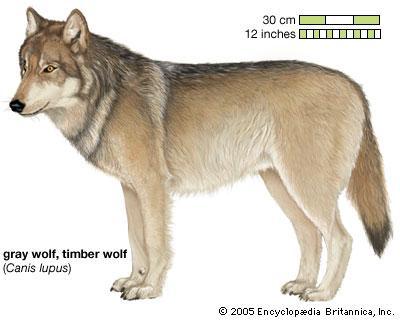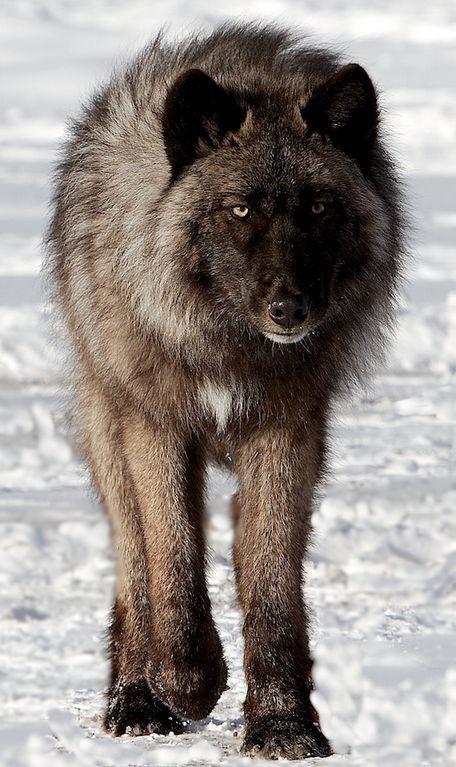The first image is the image on the left, the second image is the image on the right. Considering the images on both sides, is "A non-canine mammal can be seen in one or more of the images." valid? Answer yes or no. No. The first image is the image on the left, the second image is the image on the right. Considering the images on both sides, is "There are no more than two wolves." valid? Answer yes or no. Yes. 